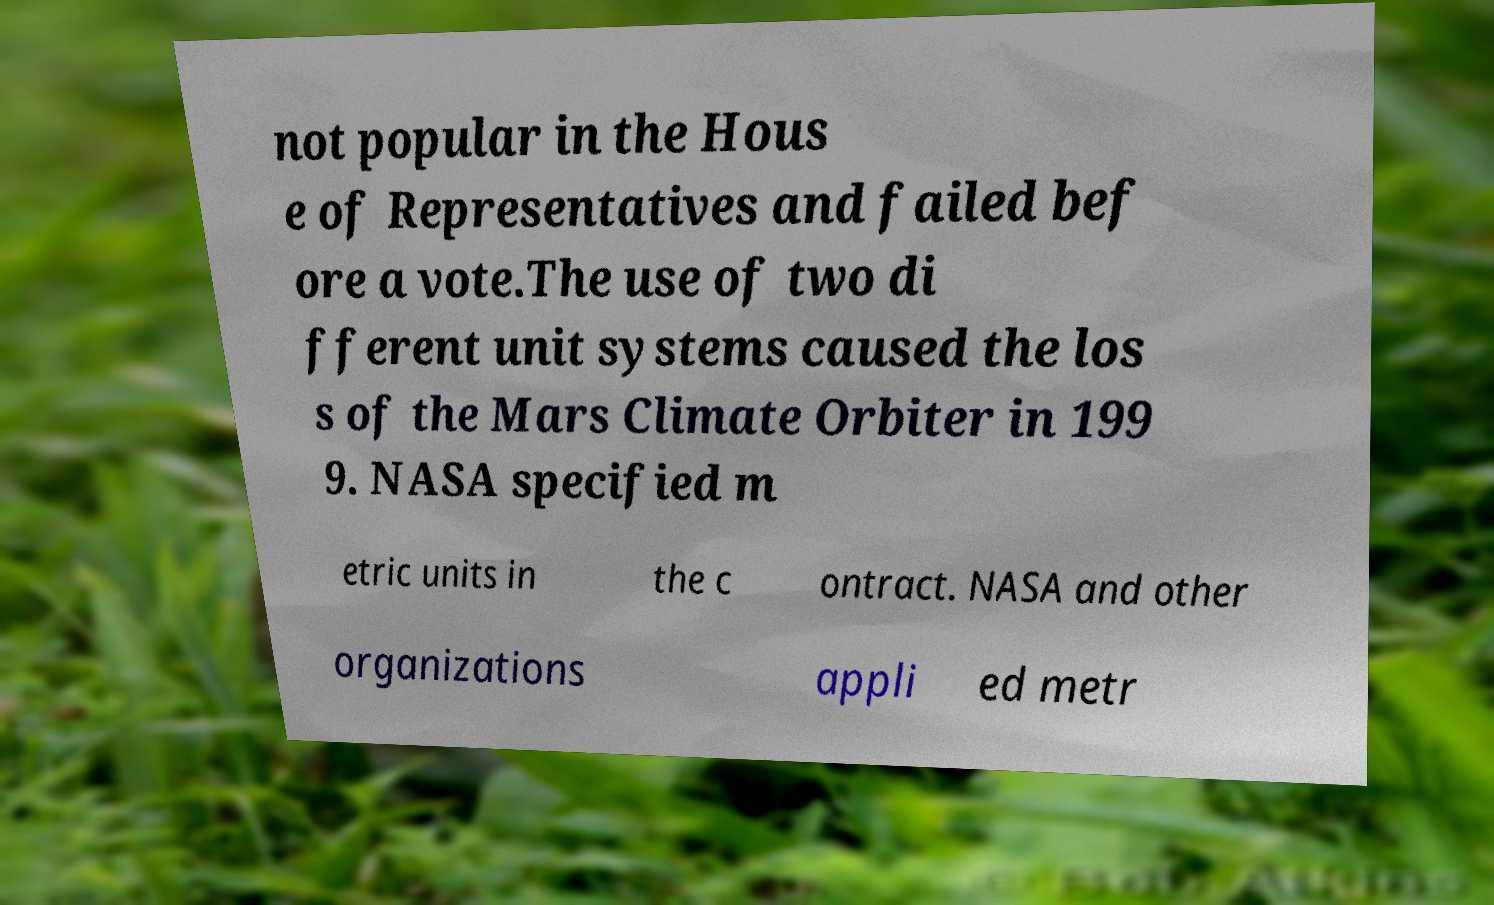I need the written content from this picture converted into text. Can you do that? not popular in the Hous e of Representatives and failed bef ore a vote.The use of two di fferent unit systems caused the los s of the Mars Climate Orbiter in 199 9. NASA specified m etric units in the c ontract. NASA and other organizations appli ed metr 